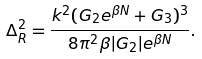Convert formula to latex. <formula><loc_0><loc_0><loc_500><loc_500>\Delta _ { R } ^ { 2 } = \frac { k ^ { 2 } ( G _ { 2 } e ^ { \beta N } + G _ { 3 } ) ^ { 3 } } { 8 \pi ^ { 2 } \beta | G _ { 2 } | e ^ { \beta N } } .</formula> 